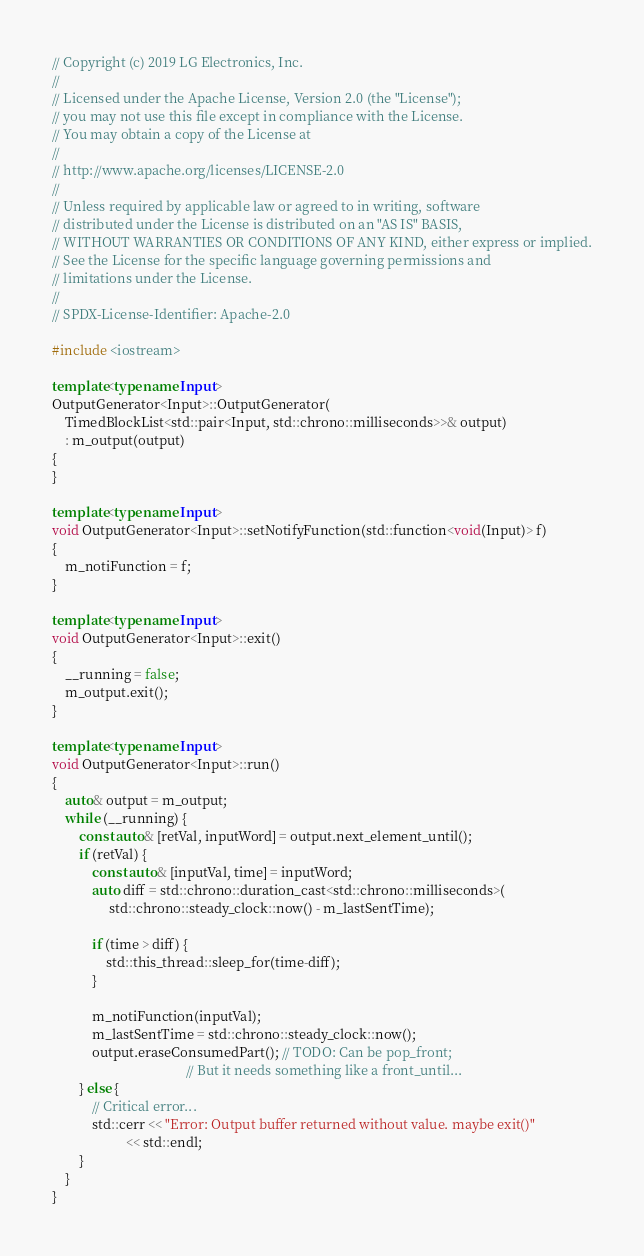<code> <loc_0><loc_0><loc_500><loc_500><_C++_>// Copyright (c) 2019 LG Electronics, Inc.
//
// Licensed under the Apache License, Version 2.0 (the "License");
// you may not use this file except in compliance with the License.
// You may obtain a copy of the License at
//
// http://www.apache.org/licenses/LICENSE-2.0
//
// Unless required by applicable law or agreed to in writing, software
// distributed under the License is distributed on an "AS IS" BASIS,
// WITHOUT WARRANTIES OR CONDITIONS OF ANY KIND, either express or implied.
// See the License for the specific language governing permissions and
// limitations under the License.
//
// SPDX-License-Identifier: Apache-2.0

#include <iostream>

template<typename Input>
OutputGenerator<Input>::OutputGenerator(
    TimedBlockList<std::pair<Input, std::chrono::milliseconds>>& output)
    : m_output(output)
{
}

template<typename Input>
void OutputGenerator<Input>::setNotifyFunction(std::function<void(Input)> f)
{
    m_notiFunction = f;
}

template<typename Input>
void OutputGenerator<Input>::exit()
{
    __running = false;
    m_output.exit();
}

template<typename Input>
void OutputGenerator<Input>::run()
{
    auto& output = m_output;
    while (__running) {
        const auto& [retVal, inputWord] = output.next_element_until();
        if (retVal) {
            const auto& [inputVal, time] = inputWord;
            auto diff = std::chrono::duration_cast<std::chrono::milliseconds>(
                 std::chrono::steady_clock::now() - m_lastSentTime);

            if (time > diff) {
                std::this_thread::sleep_for(time-diff);
            }

            m_notiFunction(inputVal);
            m_lastSentTime = std::chrono::steady_clock::now();
            output.eraseConsumedPart(); // TODO: Can be pop_front;
                                        // But it needs something like a front_until...
        } else {
            // Critical error...
            std::cerr << "Error: Output buffer returned without value. maybe exit()"
                      << std::endl;
        }
    }
}
</code> 